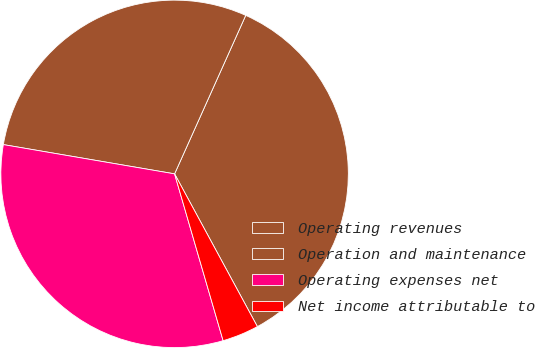<chart> <loc_0><loc_0><loc_500><loc_500><pie_chart><fcel>Operating revenues<fcel>Operation and maintenance<fcel>Operating expenses net<fcel>Net income attributable to<nl><fcel>35.38%<fcel>29.02%<fcel>32.2%<fcel>3.4%<nl></chart> 